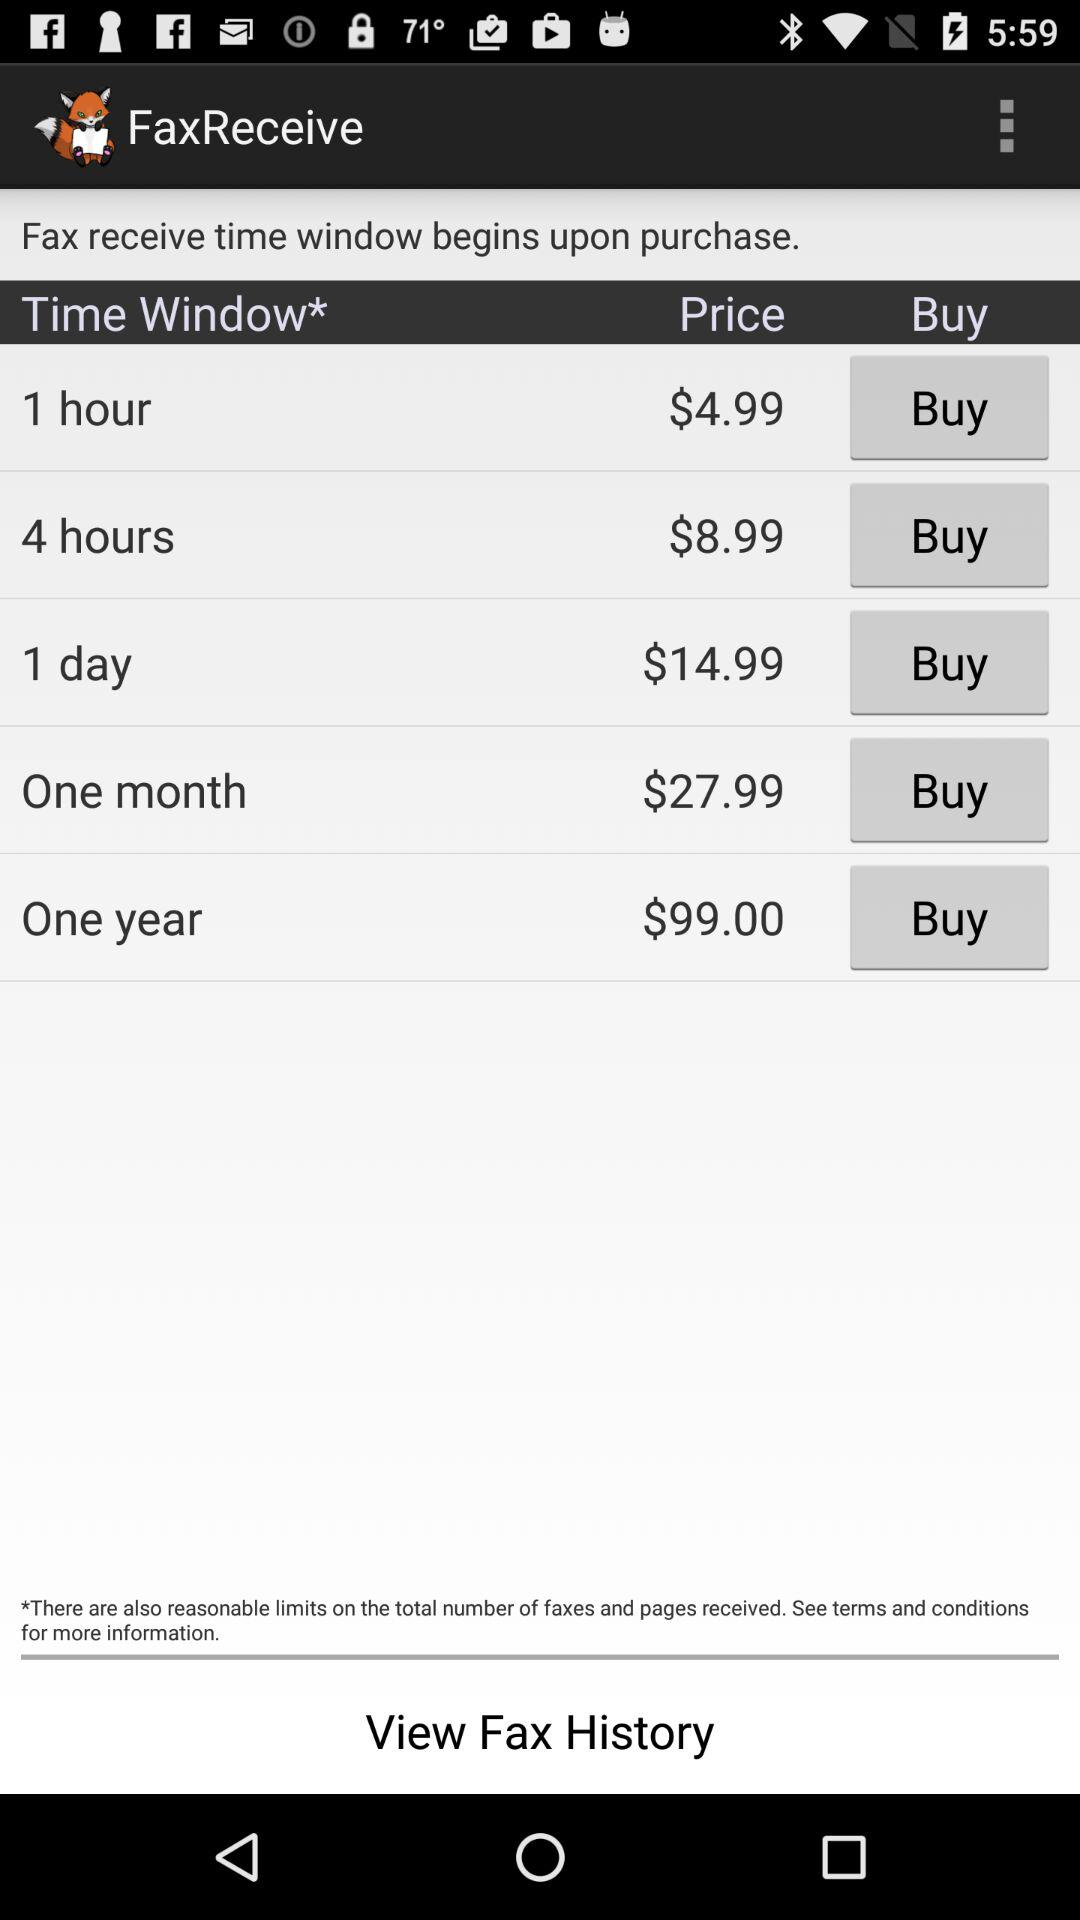How much of a time window do we get on the $99.00 price? The time window is one year. 